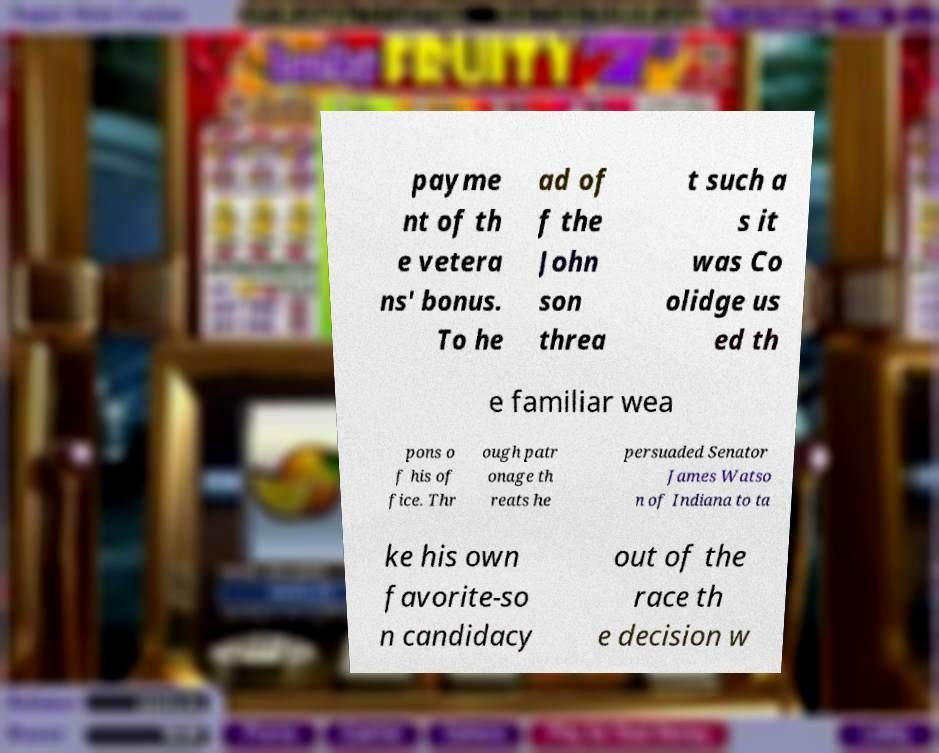What messages or text are displayed in this image? I need them in a readable, typed format. payme nt of th e vetera ns' bonus. To he ad of f the John son threa t such a s it was Co olidge us ed th e familiar wea pons o f his of fice. Thr ough patr onage th reats he persuaded Senator James Watso n of Indiana to ta ke his own favorite-so n candidacy out of the race th e decision w 